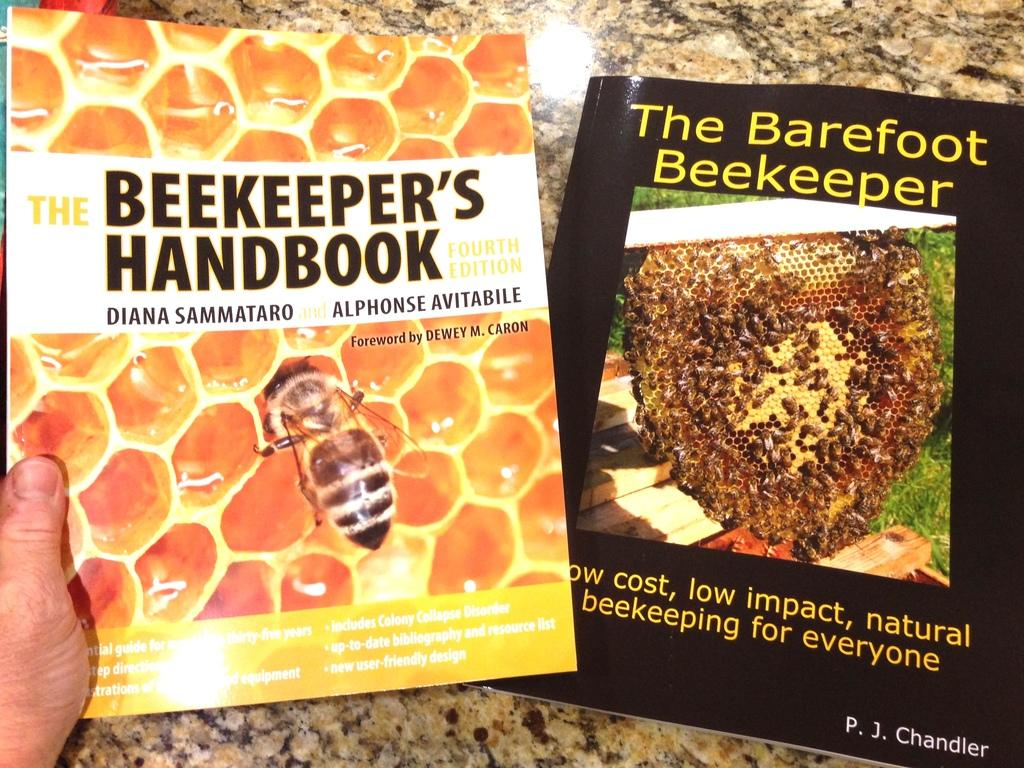What is the person's hand holding in the image? The person's hand is holding a book in the image. Are there any other books visible in the image? Yes, there is another book is on the table in the image. What type of mask is the manager wearing in the image? There is no manager or mask present in the image; it only shows a person's hand holding a book and another book on the table. 